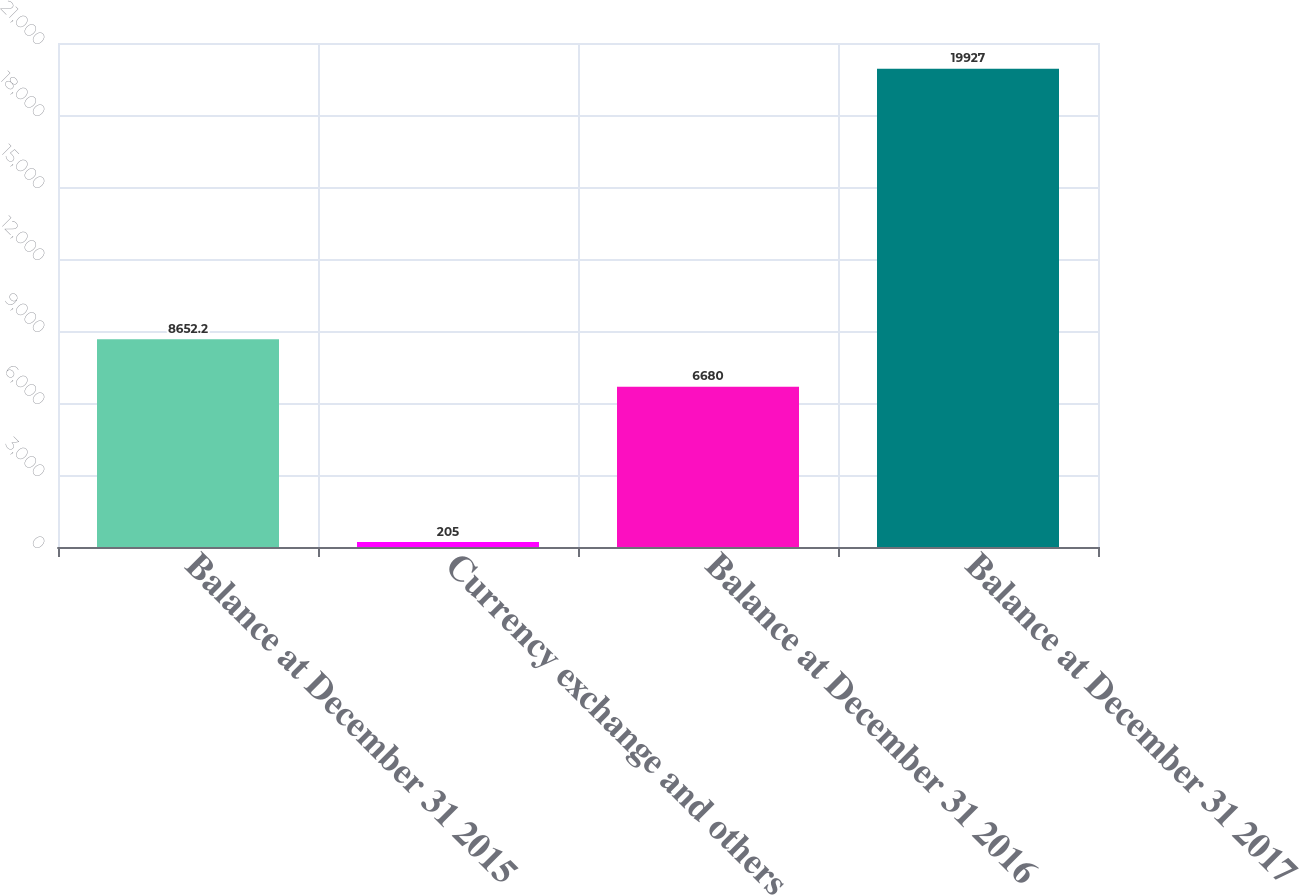<chart> <loc_0><loc_0><loc_500><loc_500><bar_chart><fcel>Balance at December 31 2015<fcel>Currency exchange and others<fcel>Balance at December 31 2016<fcel>Balance at December 31 2017<nl><fcel>8652.2<fcel>205<fcel>6680<fcel>19927<nl></chart> 